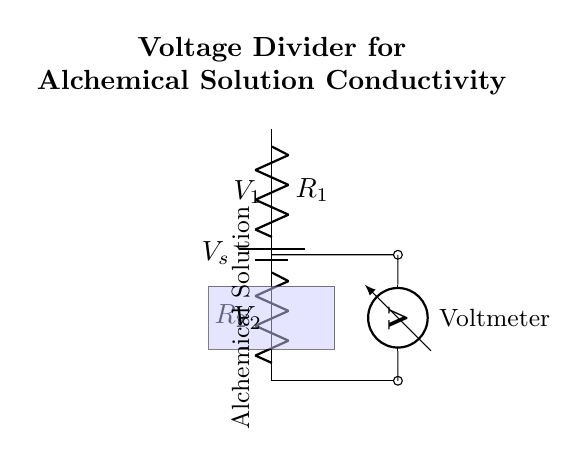What is the source voltage in the circuit? The source voltage is indicated by the label V_s connected to the battery.
Answer: V_s What are the resistance values present in the circuit? The circuit has two resistors, labeled R_1 and R_2, representing the resistance values used in the voltage divider configuration.
Answer: R_1, R_2 What is the purpose of the voltmeter in this circuit? The voltmeter measures the voltage across the resistors, specifically V_2, which indicates the voltage drop across R_2 that is related to the conductivity of the alchemical solution.
Answer: Measure voltage Which part of the circuit represents the alchemical solution? The blue rectangle in the circuit diagram represents the alchemical solution, which is where the electrical conductivity is being tested.
Answer: Blue rectangle How does the voltage divider formula apply in this circuit? The voltage divider formula, V_2 = (R_2 / (R_1 + R_2)) * V_s, is used to determine the output voltage across R_2 based on the resistances R_1 and R_2, and the input source voltage V_s.
Answer: Output voltage formula What does a higher conductivity of the alchemical solution imply for V_2? A higher conductivity causes a decrease in the total resistance of the circuit, which results in an increase in the voltage V_2 across R_2, as per the voltage divider rules.
Answer: Higher V_2 